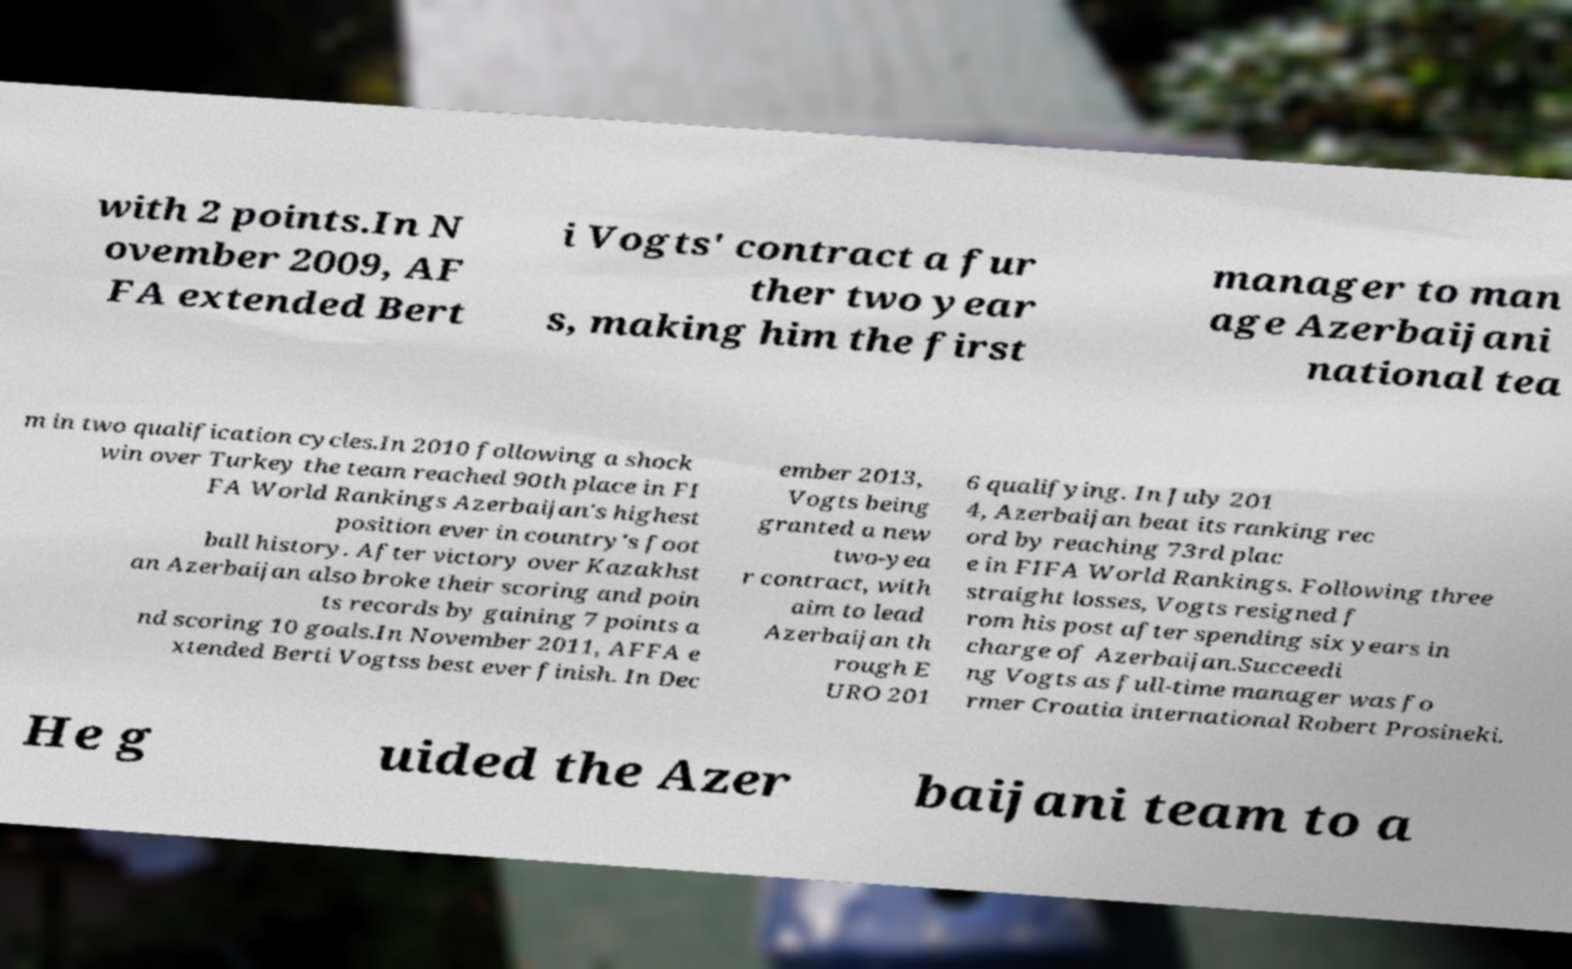For documentation purposes, I need the text within this image transcribed. Could you provide that? with 2 points.In N ovember 2009, AF FA extended Bert i Vogts' contract a fur ther two year s, making him the first manager to man age Azerbaijani national tea m in two qualification cycles.In 2010 following a shock win over Turkey the team reached 90th place in FI FA World Rankings Azerbaijan's highest position ever in country's foot ball history. After victory over Kazakhst an Azerbaijan also broke their scoring and poin ts records by gaining 7 points a nd scoring 10 goals.In November 2011, AFFA e xtended Berti Vogtss best ever finish. In Dec ember 2013, Vogts being granted a new two-yea r contract, with aim to lead Azerbaijan th rough E URO 201 6 qualifying. In July 201 4, Azerbaijan beat its ranking rec ord by reaching 73rd plac e in FIFA World Rankings. Following three straight losses, Vogts resigned f rom his post after spending six years in charge of Azerbaijan.Succeedi ng Vogts as full-time manager was fo rmer Croatia international Robert Prosineki. He g uided the Azer baijani team to a 